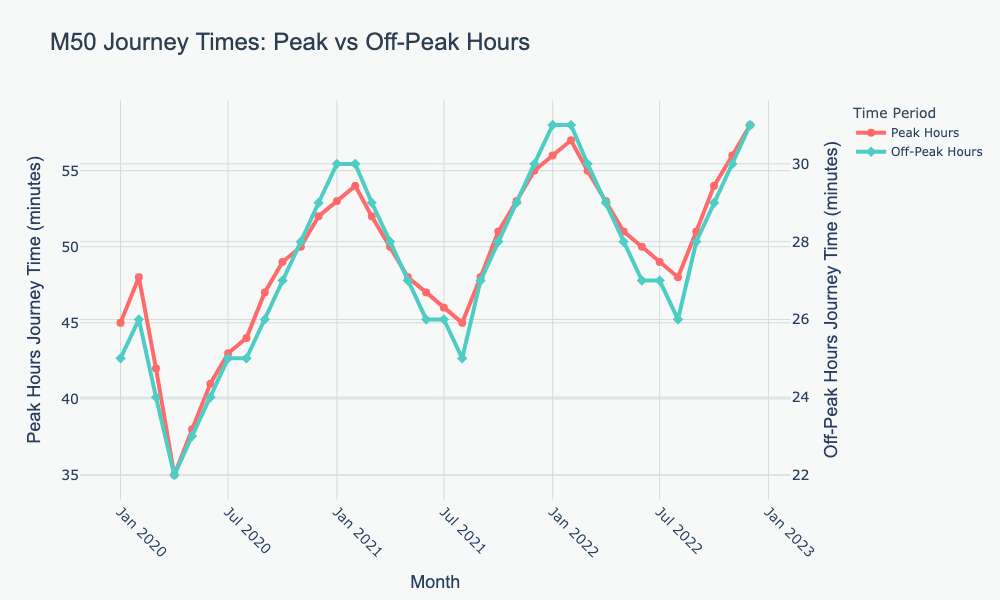What is the highest journey time during peak hours? The highest peak hour journey time corresponds to the highest point on the red line on the chart. This occurs in December 2022.
Answer: 58 minutes How does the journey time in April 2020 compare to April 2021 for peak hours? Look at the journey times for April 2020 and April 2021 on the red line. April 2020 has approximately 35 minutes, and April 2021 has approximately 50 minutes.
Answer: April 2021 is 15 minutes longer What was the journey time difference between peak and off-peak hours in December 2021? Check December 2021 values for both lines. Peak hours are around 55 minutes and off-peak are 30 minutes. The difference is 55 - 30.
Answer: 25 minutes In which month did peak hour journey times start to increase significantly after initially falling in 2020? Observe the trend in the red line for 2020. After April 2020, journey times increase through to December 2020.
Answer: April 2020 What is the average journey time during off-peak hours in 2022? Add the off-peak journey times for each month of 2022 and divide by 12: (31 + 31 + 30 + 29 + 28 + 27 + 27 + 26 + 28 + 29 + 30 + 31) / 12.
Answer: 29.25 minutes Which month in 2021 had the shortest journey time during off-peak hours? Check the green line for off-peak hours in 2021. July shows the lowest point.
Answer: July 2021 Is there a month in which peak and off-peak journey times are equal? Compare both lines each month. They are not equal any month.
Answer: No What is the trend for peak hour journey times from January 2022 to December 2022? Follow the red line from January 2022 to December 2022. The trend is upward.
Answer: Increasing What color represents off-peak journey times? Identify the color of the off-peak line on the chart.
Answer: Green 